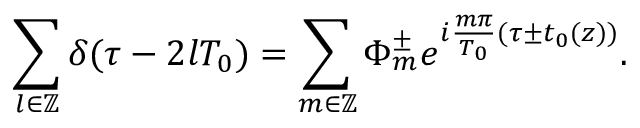Convert formula to latex. <formula><loc_0><loc_0><loc_500><loc_500>\sum _ { l \in \mathbb { Z } } \delta ( \tau - 2 l T _ { 0 } ) = \sum _ { m \in \mathbb { Z } } \Phi _ { m } ^ { \pm } e ^ { i \frac { m \pi } { T _ { 0 } } ( \tau \pm t _ { 0 } ( z ) ) } .</formula> 